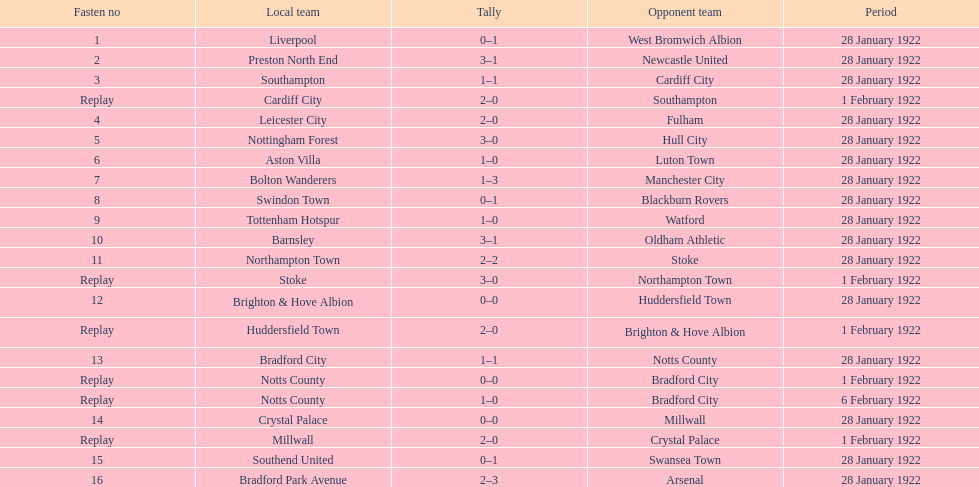Who is the first home team listed as having a score of 3-1? Preston North End. 